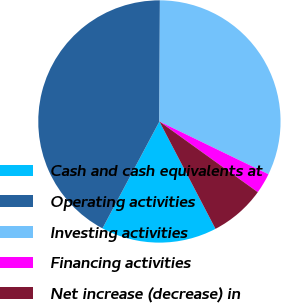<chart> <loc_0><loc_0><loc_500><loc_500><pie_chart><fcel>Cash and cash equivalents at<fcel>Operating activities<fcel>Investing activities<fcel>Financing activities<fcel>Net increase (decrease) in<nl><fcel>15.45%<fcel>42.27%<fcel>32.11%<fcel>2.74%<fcel>7.42%<nl></chart> 